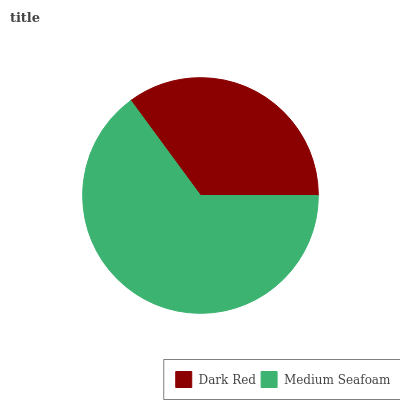Is Dark Red the minimum?
Answer yes or no. Yes. Is Medium Seafoam the maximum?
Answer yes or no. Yes. Is Medium Seafoam the minimum?
Answer yes or no. No. Is Medium Seafoam greater than Dark Red?
Answer yes or no. Yes. Is Dark Red less than Medium Seafoam?
Answer yes or no. Yes. Is Dark Red greater than Medium Seafoam?
Answer yes or no. No. Is Medium Seafoam less than Dark Red?
Answer yes or no. No. Is Medium Seafoam the high median?
Answer yes or no. Yes. Is Dark Red the low median?
Answer yes or no. Yes. Is Dark Red the high median?
Answer yes or no. No. Is Medium Seafoam the low median?
Answer yes or no. No. 